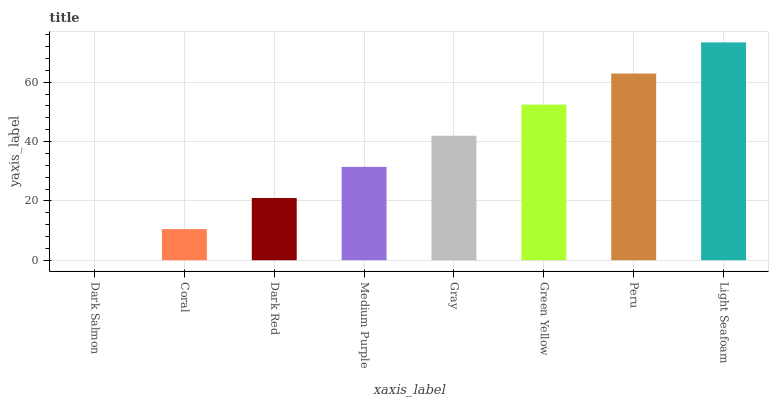Is Dark Salmon the minimum?
Answer yes or no. Yes. Is Light Seafoam the maximum?
Answer yes or no. Yes. Is Coral the minimum?
Answer yes or no. No. Is Coral the maximum?
Answer yes or no. No. Is Coral greater than Dark Salmon?
Answer yes or no. Yes. Is Dark Salmon less than Coral?
Answer yes or no. Yes. Is Dark Salmon greater than Coral?
Answer yes or no. No. Is Coral less than Dark Salmon?
Answer yes or no. No. Is Gray the high median?
Answer yes or no. Yes. Is Medium Purple the low median?
Answer yes or no. Yes. Is Coral the high median?
Answer yes or no. No. Is Light Seafoam the low median?
Answer yes or no. No. 